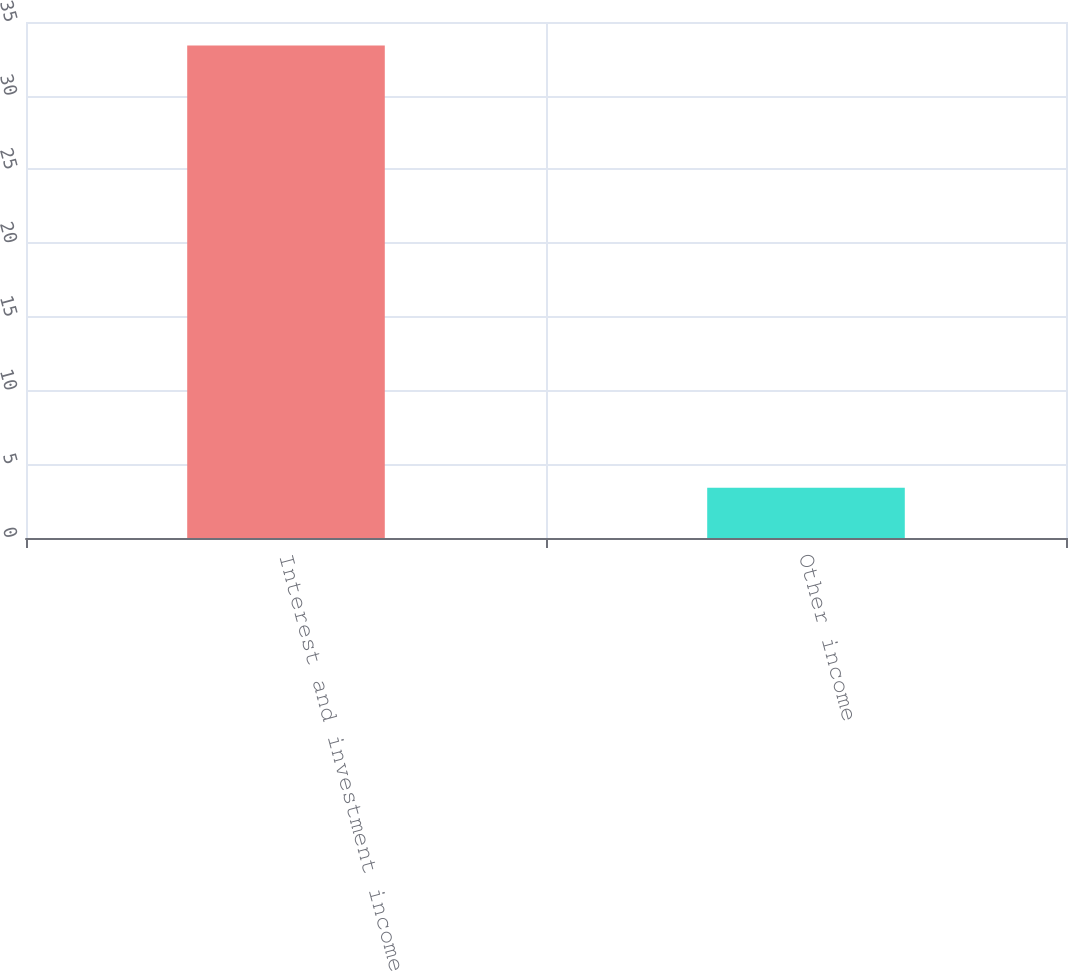Convert chart to OTSL. <chart><loc_0><loc_0><loc_500><loc_500><bar_chart><fcel>Interest and investment income<fcel>Other income<nl><fcel>33.4<fcel>3.4<nl></chart> 